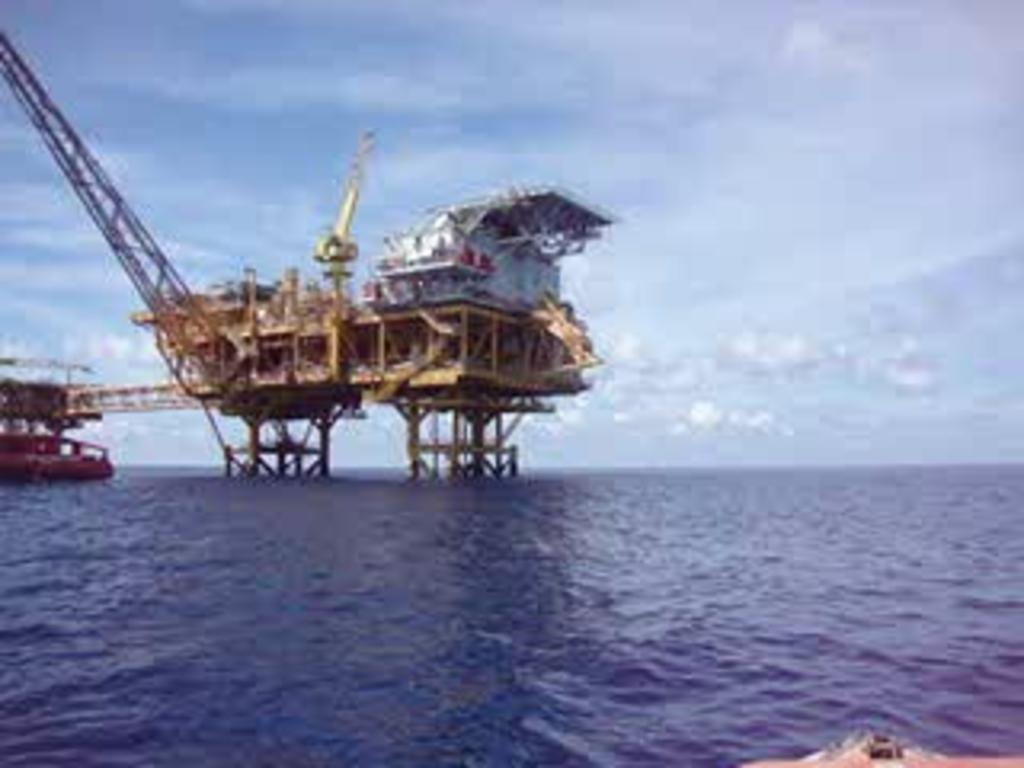Could you give a brief overview of what you see in this image? This is a blurred image. In this image I can see the bridge, crane and boats on the water. In the background I can see the clouds and the sky. 